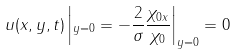<formula> <loc_0><loc_0><loc_500><loc_500>u ( x , y , t ) \left | _ { y = 0 } = - \frac { 2 } { \sigma } \frac { \chi _ { 0 x } } { \chi _ { 0 } } \right | _ { y = 0 } = 0</formula> 